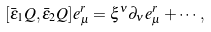Convert formula to latex. <formula><loc_0><loc_0><loc_500><loc_500>[ \bar { \epsilon } _ { 1 } Q , \bar { \epsilon } _ { 2 } Q ] e _ { \mu } ^ { r } = \xi ^ { \nu } \partial _ { \nu } e _ { \mu } ^ { r } + \cdots ,</formula> 